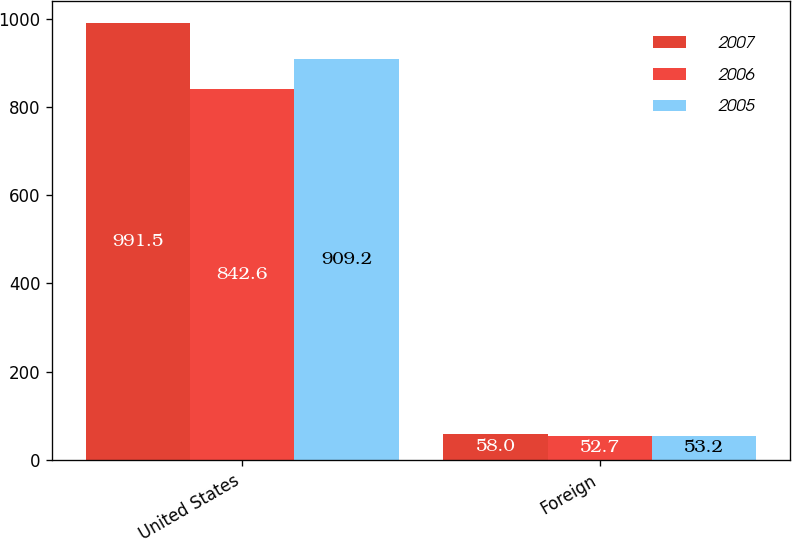Convert chart to OTSL. <chart><loc_0><loc_0><loc_500><loc_500><stacked_bar_chart><ecel><fcel>United States<fcel>Foreign<nl><fcel>2007<fcel>991.5<fcel>58<nl><fcel>2006<fcel>842.6<fcel>52.7<nl><fcel>2005<fcel>909.2<fcel>53.2<nl></chart> 